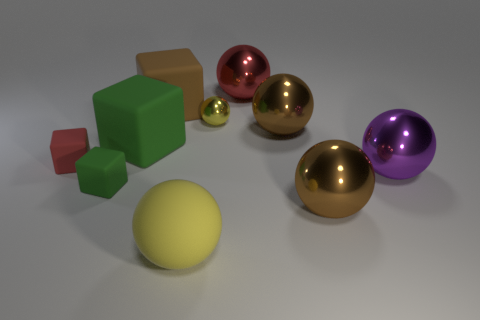Subtract all large yellow rubber balls. How many balls are left? 5 Subtract all brown spheres. How many spheres are left? 4 Subtract all green cylinders. How many yellow balls are left? 2 Subtract 4 spheres. How many spheres are left? 2 Subtract all balls. How many objects are left? 4 Subtract all gray spheres. Subtract all purple cylinders. How many spheres are left? 6 Subtract all small brown metal cylinders. Subtract all matte balls. How many objects are left? 9 Add 9 big brown cubes. How many big brown cubes are left? 10 Add 3 purple rubber objects. How many purple rubber objects exist? 3 Subtract 0 yellow cubes. How many objects are left? 10 